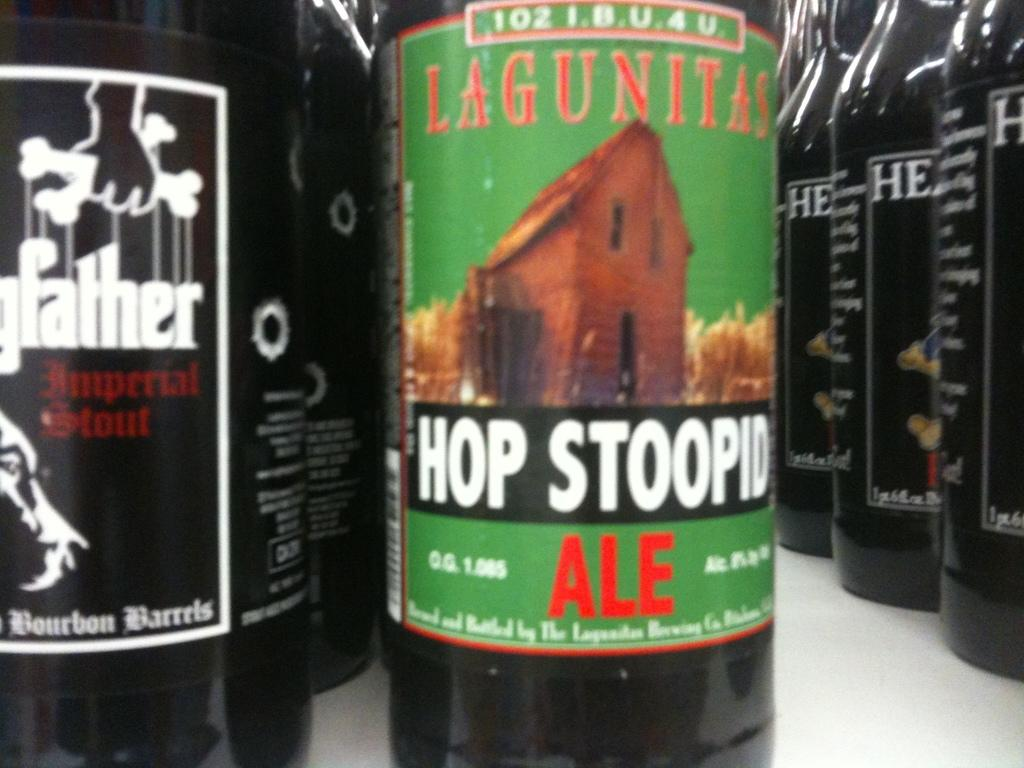<image>
Write a terse but informative summary of the picture. A dark ale glass bottle made by Lagunita 